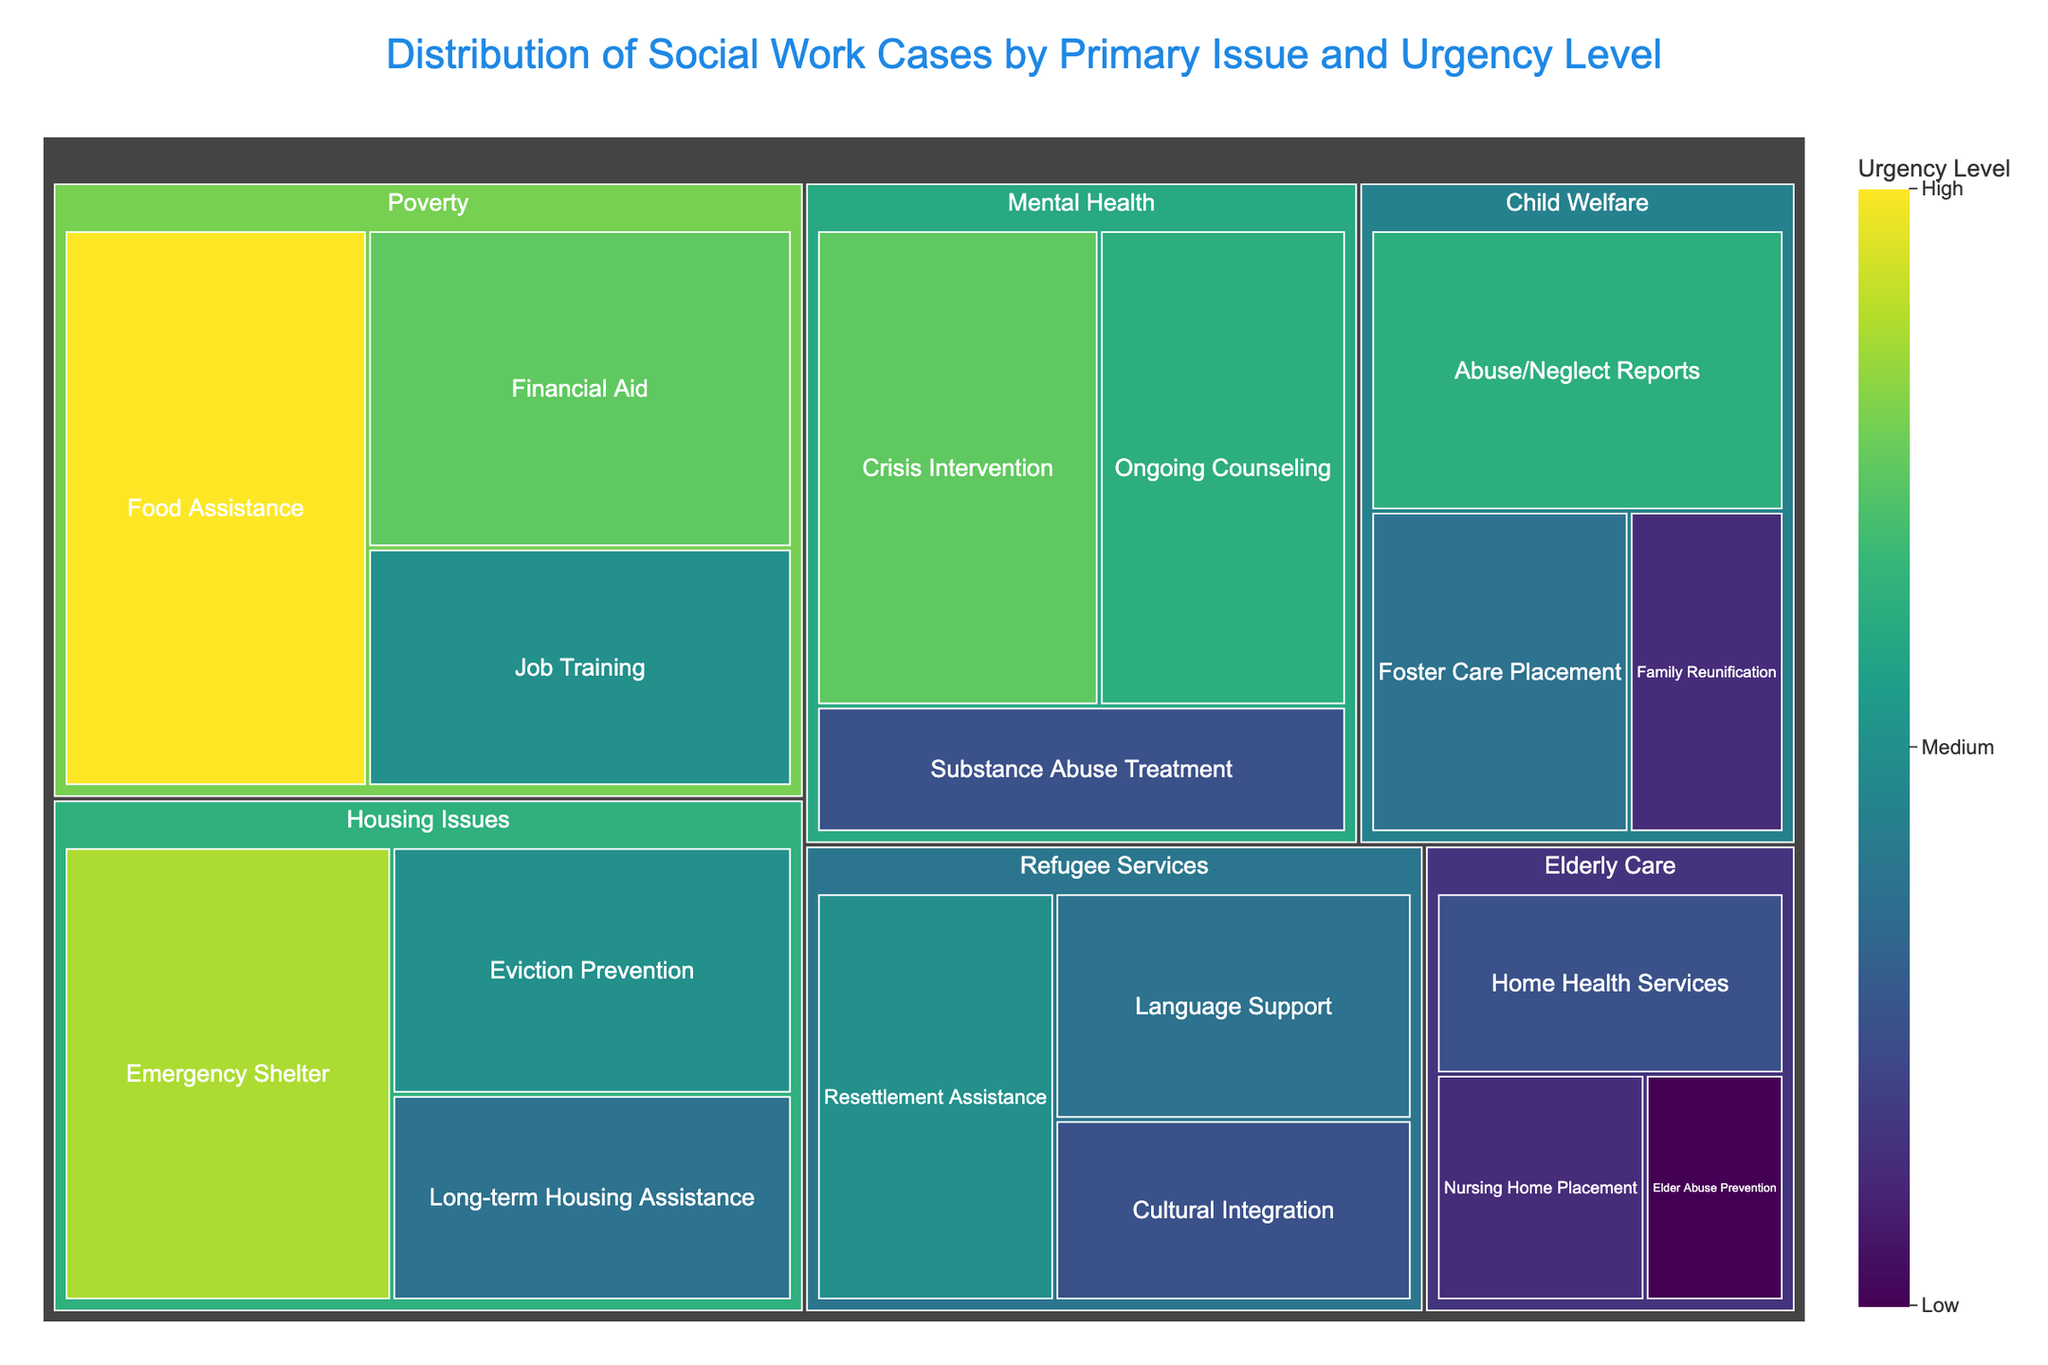What's the title of the figure? The title is centered at the top of the figure in a large font. It reads "Distribution of Social Work Cases by Primary Issue and Urgency Level".
Answer: Distribution of Social Work Cases by Primary Issue and Urgency Level How many subcategories are in the "Mental Health" category? The "Mental Health" category has three subcategories displayed in the figure: Crisis Intervention, Ongoing Counseling, and Substance Abuse Treatment.
Answer: 3 Which subcategory under "Poverty" has the highest urgency level? In the "Poverty" category, the subcategory with the highest urgency level is marked by the largest area. The figure shows that Food Assistance has the highest urgency level.
Answer: Food Assistance Compare the urgency levels of "Foster Care Placement" and "Family Reunification" under "Child Welfare". Which one has a higher urgency level? By comparing the sizes of the tiles under "Child Welfare", Foster Care Placement has a larger area than Family Reunification, indicating a higher urgency level.
Answer: Foster Care Placement What is the combined total urgency value for "Emergency Shelter" and "Eviction Prevention" under "Housing Issues"? Adding the urgency values of Emergency Shelter (45) and Eviction Prevention (30) results in a combined value of 75.
Answer: 75 Which category features the subcategory "Home Health Services" and what is its urgency level? "Home Health Services" is a subcategory under "Elderly Care" with an urgency level of 20, as indicated by the area of its tile in the figure.
Answer: Elderly Care, 20 Are there more cases of "Crisis Intervention" under "Mental Health" or "Job Training" under "Poverty"? By comparing the sizes of the respective tiles, Crisis Intervention (40) has more cases than Job Training (30).
Answer: Crisis Intervention What is the average urgency level for the subcategories under "Refugee Services"? The subcategories under "Refugee Services" have urgency levels of Resettlement Assistance (30), Language Support (25), and Cultural Integration (20). The average is calculated as (30 + 25 + 20) / 3 = 25.
Answer: 25 Which subcategory under "Elderly Care" has the lowest urgency level? Among the subcategories under "Elderly Care," Elder Abuse Prevention has the smallest area, indicating an urgency level of 10.
Answer: Elder Abuse Prevention 